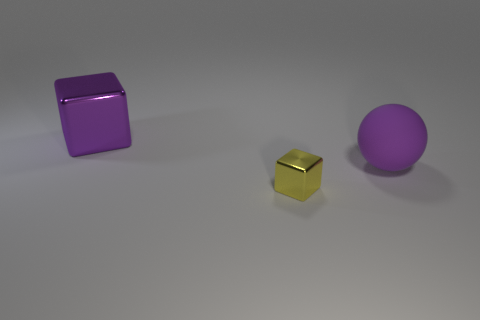How many big rubber balls are on the left side of the large object to the left of the purple matte sphere? 0 